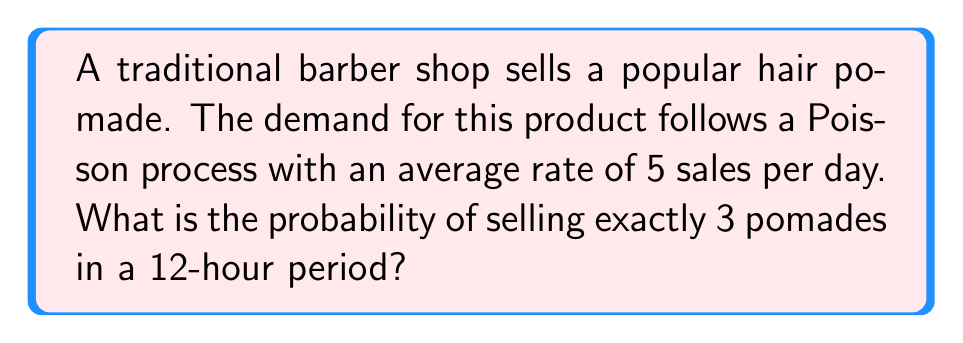Teach me how to tackle this problem. To solve this problem, we'll use the Poisson distribution formula:

$$P(X = k) = \frac{e^{-\lambda} \lambda^k}{k!}$$

Where:
- $X$ is the number of events (pomade sales)
- $k$ is the specific number of events we're interested in (3 sales)
- $\lambda$ is the average number of events in the given time period

Step 1: Calculate $\lambda$ for a 12-hour period
The average rate is 5 sales per day (24 hours), so for 12 hours:
$$\lambda = 5 \times \frac{12}{24} = 2.5$$

Step 2: Apply the Poisson distribution formula
$$P(X = 3) = \frac{e^{-2.5} 2.5^3}{3!}$$

Step 3: Calculate the numerator
$$e^{-2.5} \approx 0.0821$$
$$2.5^3 = 15.625$$
$$e^{-2.5} 2.5^3 \approx 0.0821 \times 15.625 \approx 1.2828$$

Step 4: Calculate the denominator
$$3! = 3 \times 2 \times 1 = 6$$

Step 5: Divide the numerator by the denominator
$$\frac{1.2828}{6} \approx 0.2138$$

Therefore, the probability of selling exactly 3 pomades in a 12-hour period is approximately 0.2138 or 21.38%.
Answer: 0.2138 